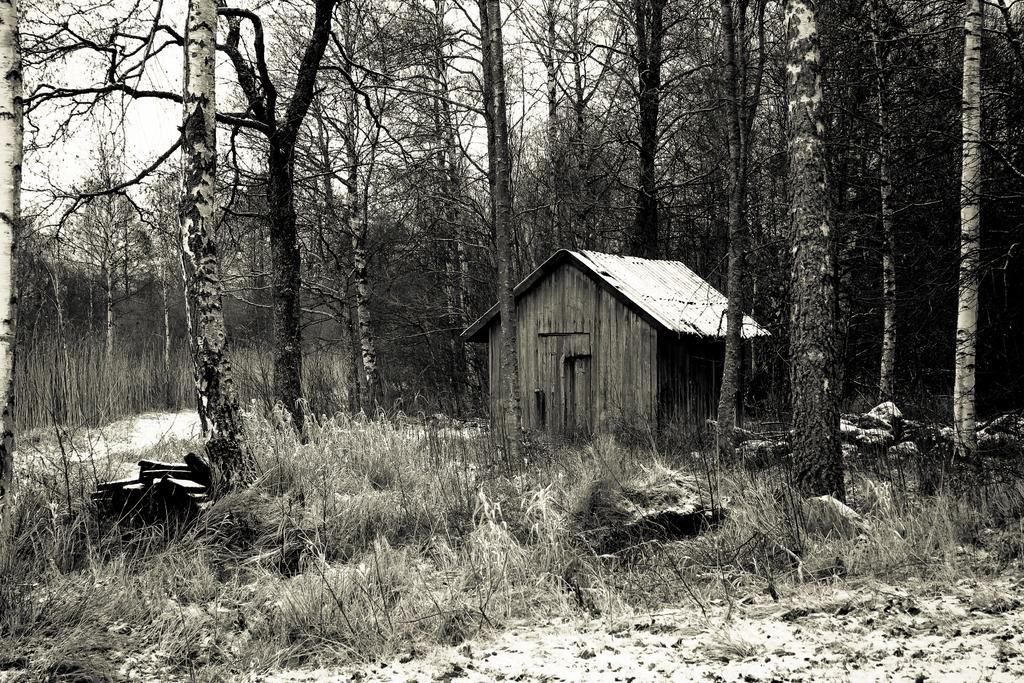What type of vegetation can be seen in the image? There are bushes and trees in the image. What structure is located in the center of the image? There is a shack in the center of the image. What colors are predominant in the image? The image has a brown and white color scheme. Can you tell me how many hens are sitting on the roof of the shack in the image? There are no hens present in the image; it only features bushes, trees, and a shack. Is there a knife visible on the ground near the shack in the image? There is no knife present in the image. 